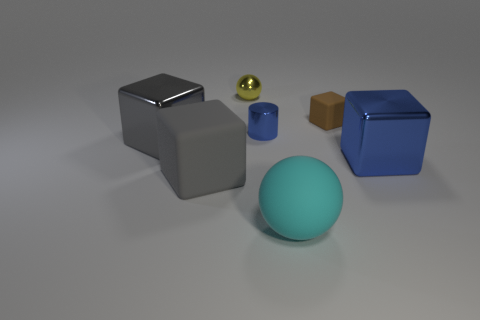Is the number of gray cubes greater than the number of blocks?
Make the answer very short. No. What is the size of the gray cube on the right side of the big shiny cube left of the small yellow object?
Your answer should be very brief. Large. The other thing that is the same shape as the large cyan object is what color?
Make the answer very short. Yellow. The gray metal cube is what size?
Provide a succinct answer. Large. How many blocks are either tiny yellow things or gray rubber things?
Give a very brief answer. 1. The blue object that is the same shape as the gray rubber thing is what size?
Provide a short and direct response. Large. What number of large matte objects are there?
Give a very brief answer. 2. There is a cyan rubber thing; is its shape the same as the blue thing that is to the right of the big ball?
Provide a succinct answer. No. There is a sphere to the left of the small blue thing; how big is it?
Your answer should be very brief. Small. What is the material of the tiny brown object?
Offer a terse response. Rubber. 